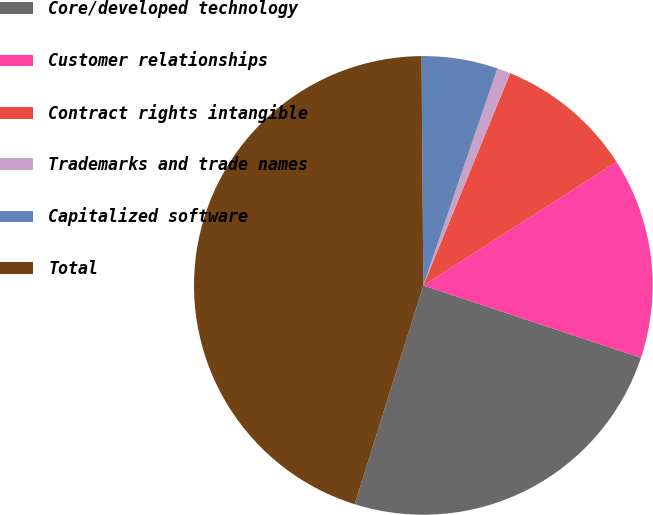<chart> <loc_0><loc_0><loc_500><loc_500><pie_chart><fcel>Core/developed technology<fcel>Customer relationships<fcel>Contract rights intangible<fcel>Trademarks and trade names<fcel>Capitalized software<fcel>Total<nl><fcel>24.72%<fcel>14.17%<fcel>9.76%<fcel>0.95%<fcel>5.36%<fcel>45.04%<nl></chart> 